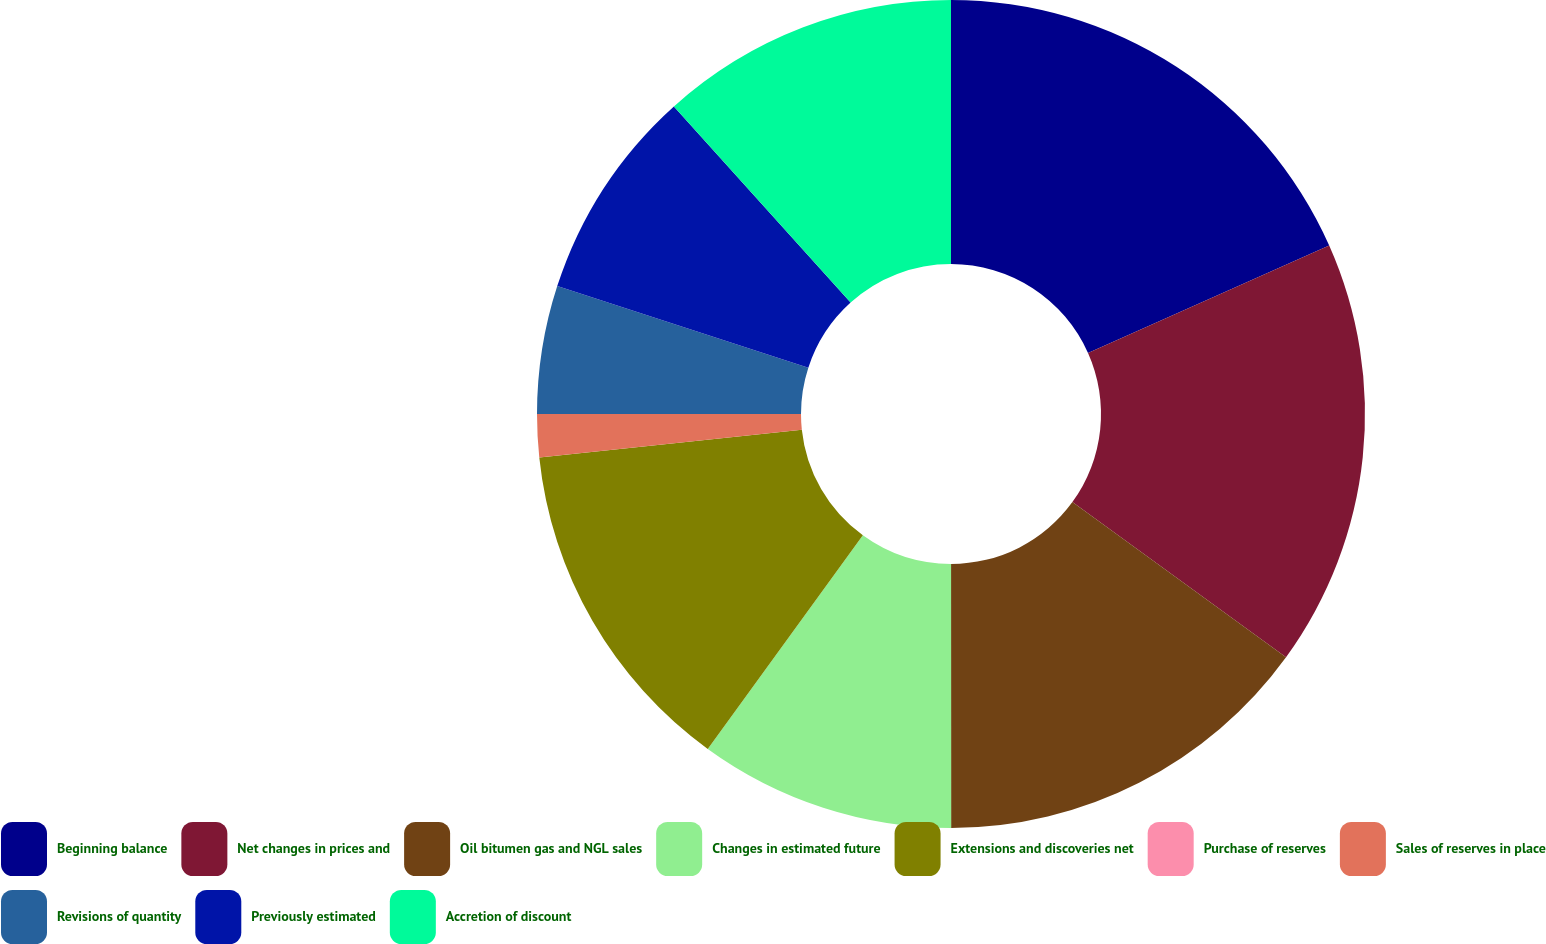Convert chart to OTSL. <chart><loc_0><loc_0><loc_500><loc_500><pie_chart><fcel>Beginning balance<fcel>Net changes in prices and<fcel>Oil bitumen gas and NGL sales<fcel>Changes in estimated future<fcel>Extensions and discoveries net<fcel>Purchase of reserves<fcel>Sales of reserves in place<fcel>Revisions of quantity<fcel>Previously estimated<fcel>Accretion of discount<nl><fcel>18.33%<fcel>16.66%<fcel>15.0%<fcel>10.0%<fcel>13.33%<fcel>0.0%<fcel>1.67%<fcel>5.0%<fcel>8.33%<fcel>11.67%<nl></chart> 